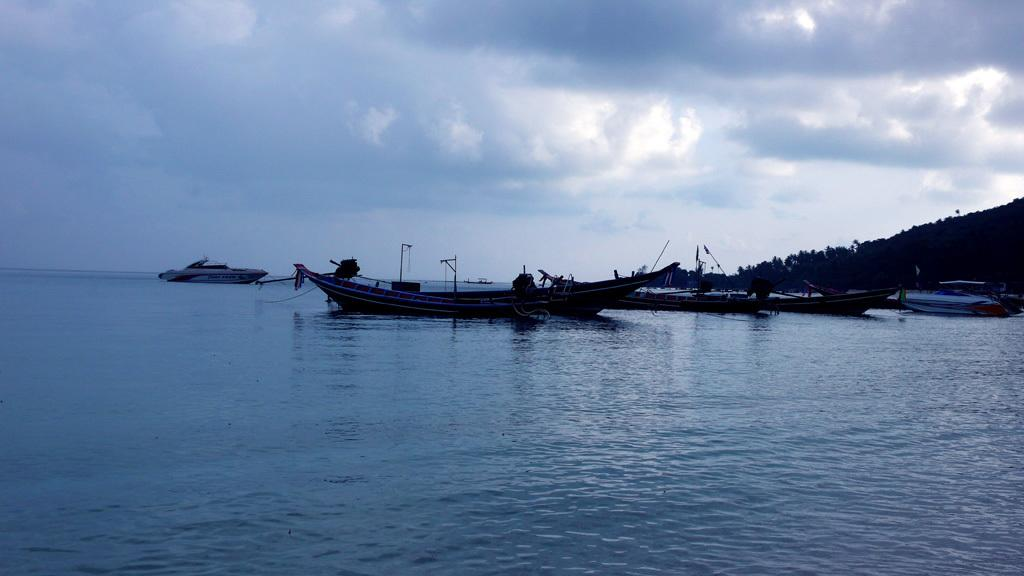What is floating on the surface of the water in the image? There are boats on the surface of the water in the image. What can be seen in the sky in the image? Clouds are present in the sky in the image. What type of vegetation is visible on the right side of the image? Trees are visible on the right side of the image. How many birds are sitting on the plate in the image? There is no plate or birds present in the image. What type of match is being played in the image? There is no match or any indication of a game being played in the image. 